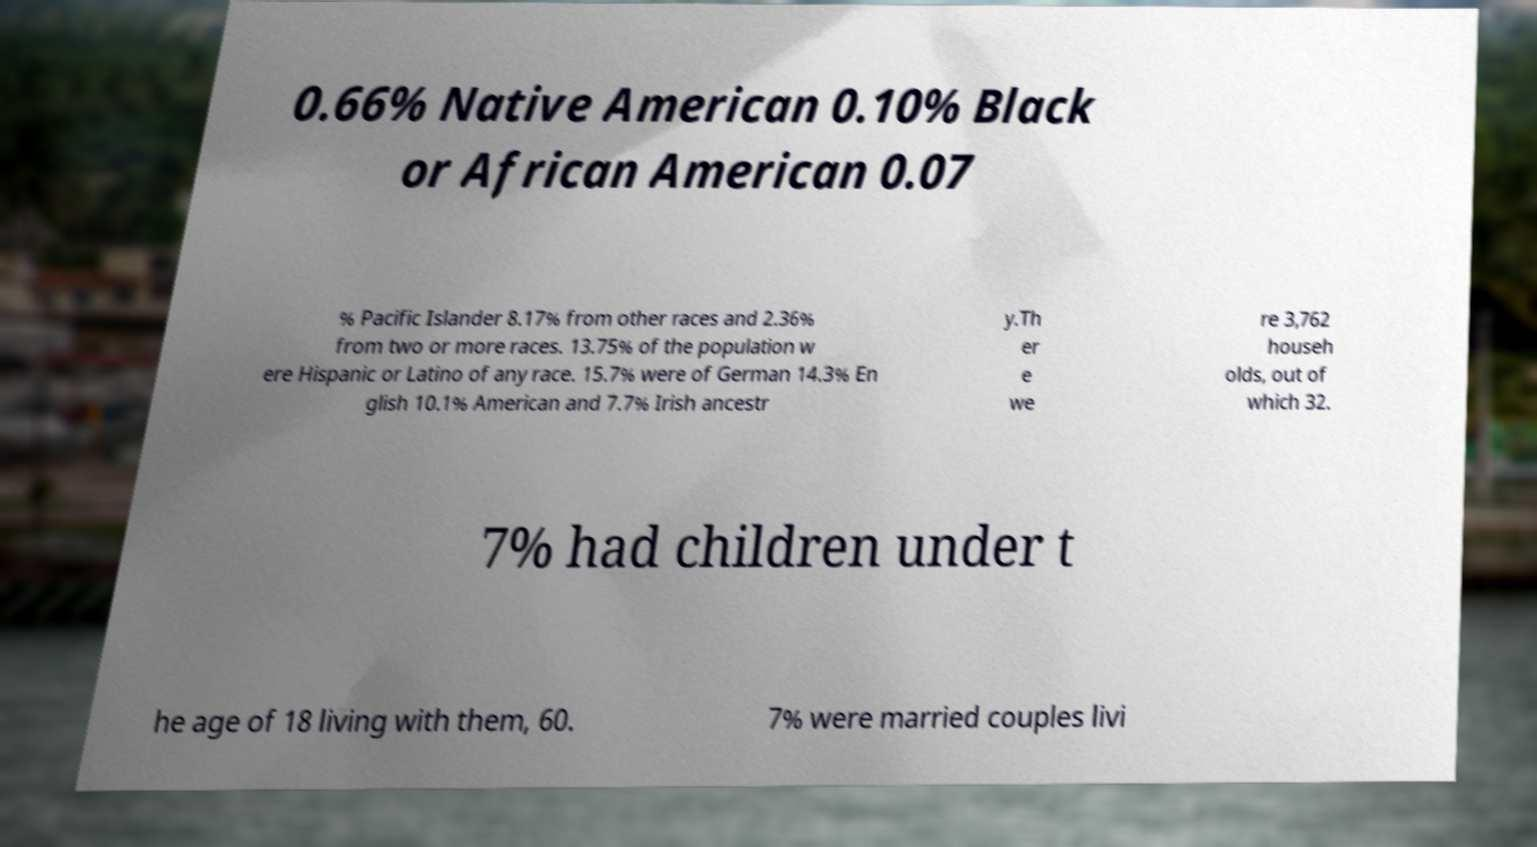There's text embedded in this image that I need extracted. Can you transcribe it verbatim? 0.66% Native American 0.10% Black or African American 0.07 % Pacific Islander 8.17% from other races and 2.36% from two or more races. 13.75% of the population w ere Hispanic or Latino of any race. 15.7% were of German 14.3% En glish 10.1% American and 7.7% Irish ancestr y.Th er e we re 3,762 househ olds, out of which 32. 7% had children under t he age of 18 living with them, 60. 7% were married couples livi 